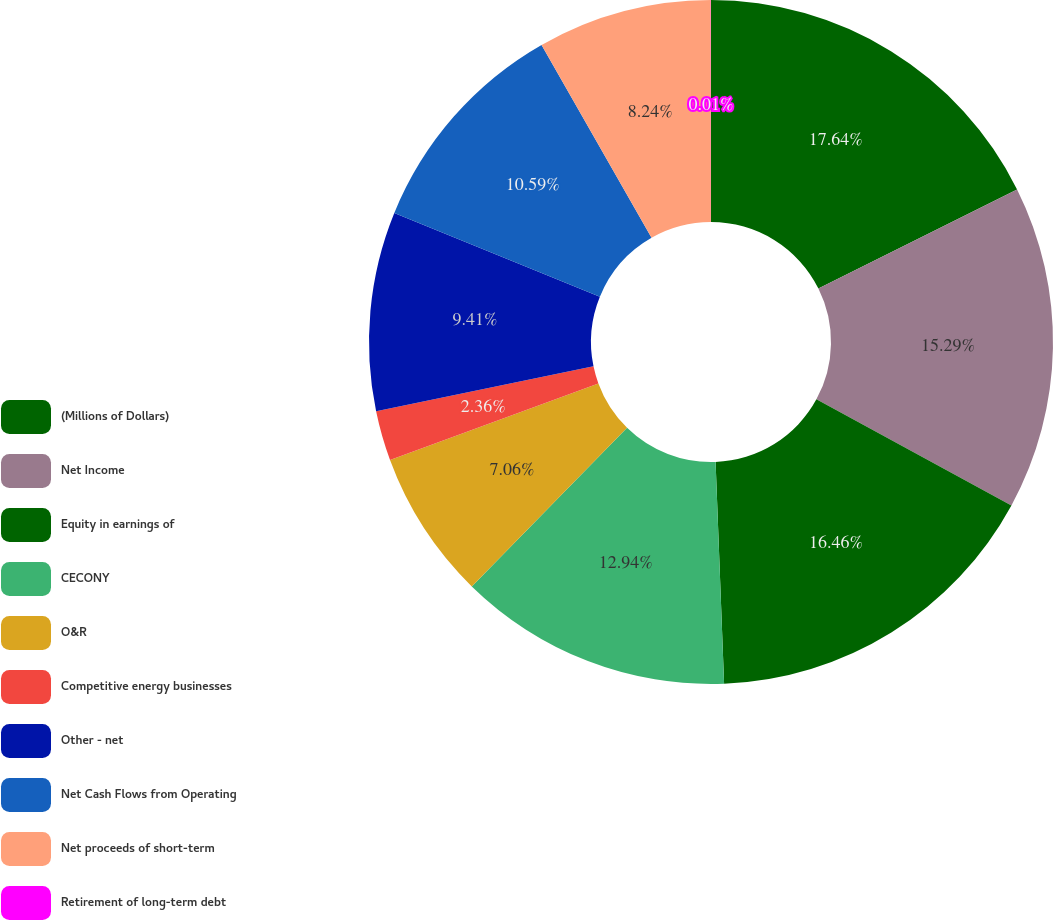Convert chart to OTSL. <chart><loc_0><loc_0><loc_500><loc_500><pie_chart><fcel>(Millions of Dollars)<fcel>Net Income<fcel>Equity in earnings of<fcel>CECONY<fcel>O&R<fcel>Competitive energy businesses<fcel>Other - net<fcel>Net Cash Flows from Operating<fcel>Net proceeds of short-term<fcel>Retirement of long-term debt<nl><fcel>17.64%<fcel>15.29%<fcel>16.46%<fcel>12.94%<fcel>7.06%<fcel>2.36%<fcel>9.41%<fcel>10.59%<fcel>8.24%<fcel>0.01%<nl></chart> 